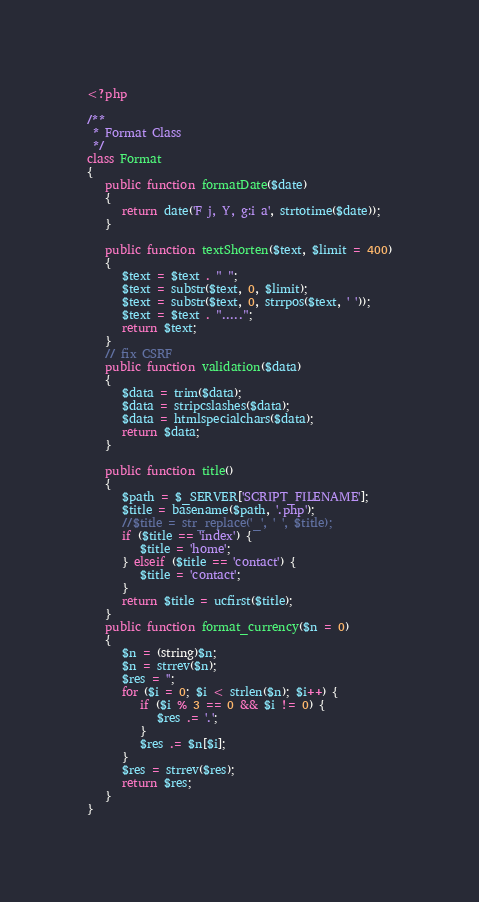<code> <loc_0><loc_0><loc_500><loc_500><_PHP_><?php

/**
 * Format Class
 */
class Format
{
   public function formatDate($date)
   {
      return date('F j, Y, g:i a', strtotime($date));
   }

   public function textShorten($text, $limit = 400)
   {
      $text = $text . " ";
      $text = substr($text, 0, $limit);
      $text = substr($text, 0, strrpos($text, ' '));
      $text = $text . ".....";
      return $text;
   }
   // fix CSRF
   public function validation($data)
   {
      $data = trim($data);
      $data = stripcslashes($data);
      $data = htmlspecialchars($data);
      return $data;
   }

   public function title()
   {
      $path = $_SERVER['SCRIPT_FILENAME'];
      $title = basename($path, '.php');
      //$title = str_replace('_', ' ', $title);
      if ($title == 'index') {
         $title = 'home';
      } elseif ($title == 'contact') {
         $title = 'contact';
      }
      return $title = ucfirst($title);
   }
   public function format_currency($n = 0)
   {
      $n = (string)$n;
      $n = strrev($n);
      $res = '';
      for ($i = 0; $i < strlen($n); $i++) {
         if ($i % 3 == 0 && $i != 0) {
            $res .= '.';
         }
         $res .= $n[$i];
      }
      $res = strrev($res);
      return $res;
   }
}
</code> 